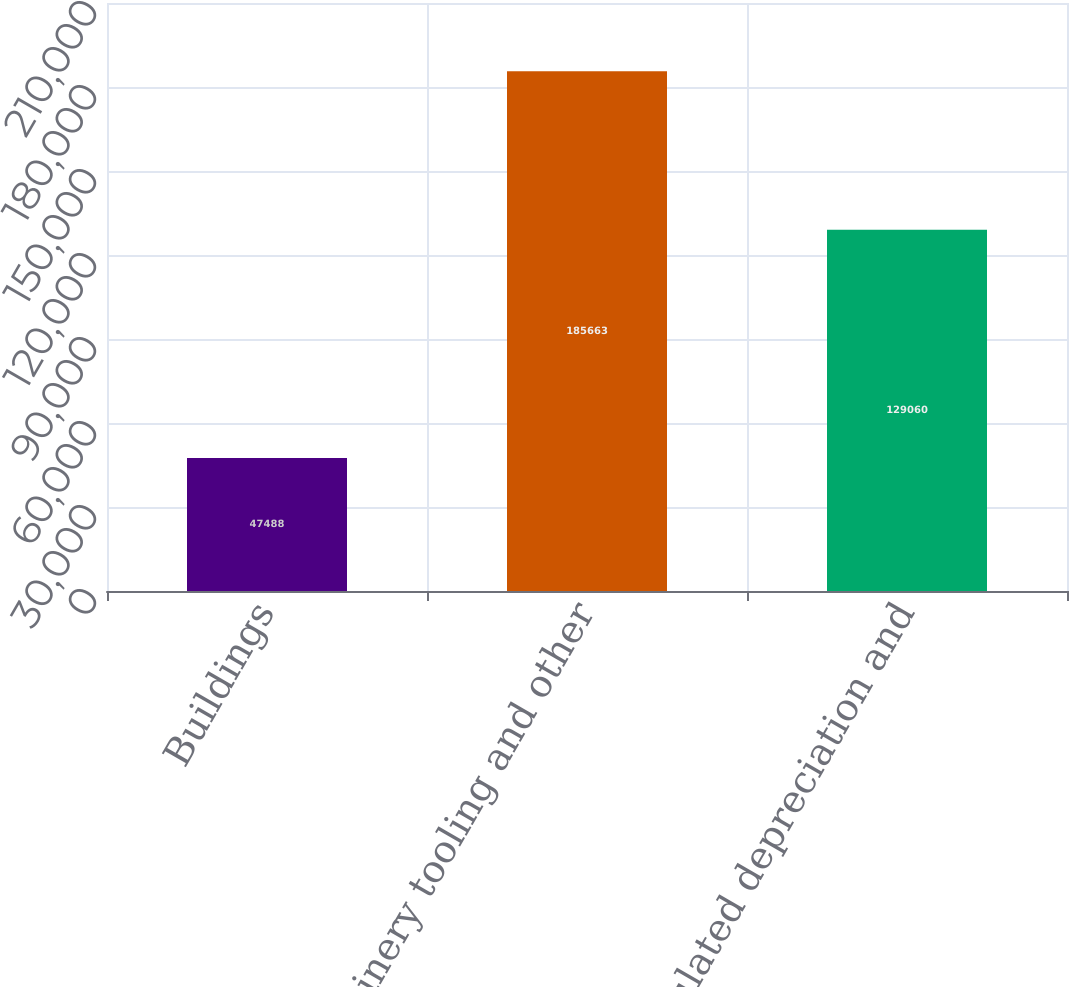<chart> <loc_0><loc_0><loc_500><loc_500><bar_chart><fcel>Buildings<fcel>Machinery tooling and other<fcel>Accumulated depreciation and<nl><fcel>47488<fcel>185663<fcel>129060<nl></chart> 